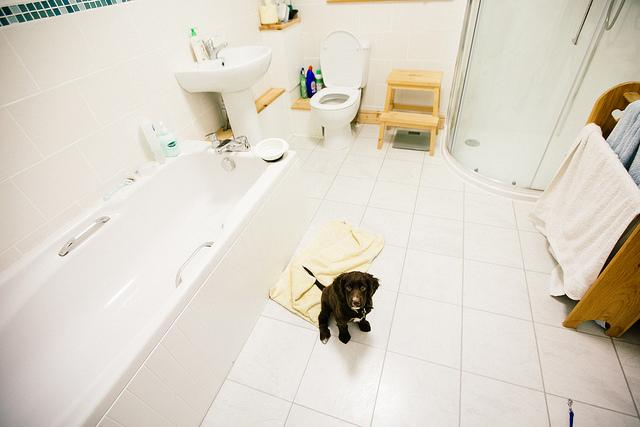Why might the dog be near the tub? Please explain your reasoning. to bathe. This is the only reason a dog might be in the bathroom, since they don't use the toilet or the sink. 